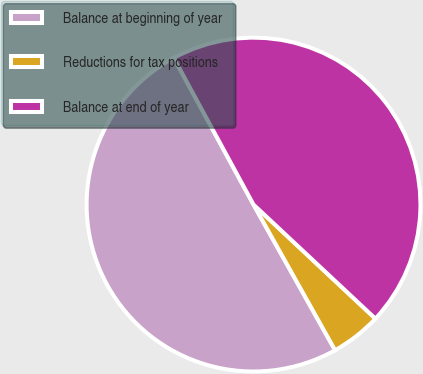Convert chart to OTSL. <chart><loc_0><loc_0><loc_500><loc_500><pie_chart><fcel>Balance at beginning of year<fcel>Reductions for tax positions<fcel>Balance at end of year<nl><fcel>50.2%<fcel>4.9%<fcel>44.9%<nl></chart> 